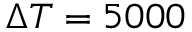<formula> <loc_0><loc_0><loc_500><loc_500>\Delta T = 5 0 0 0</formula> 